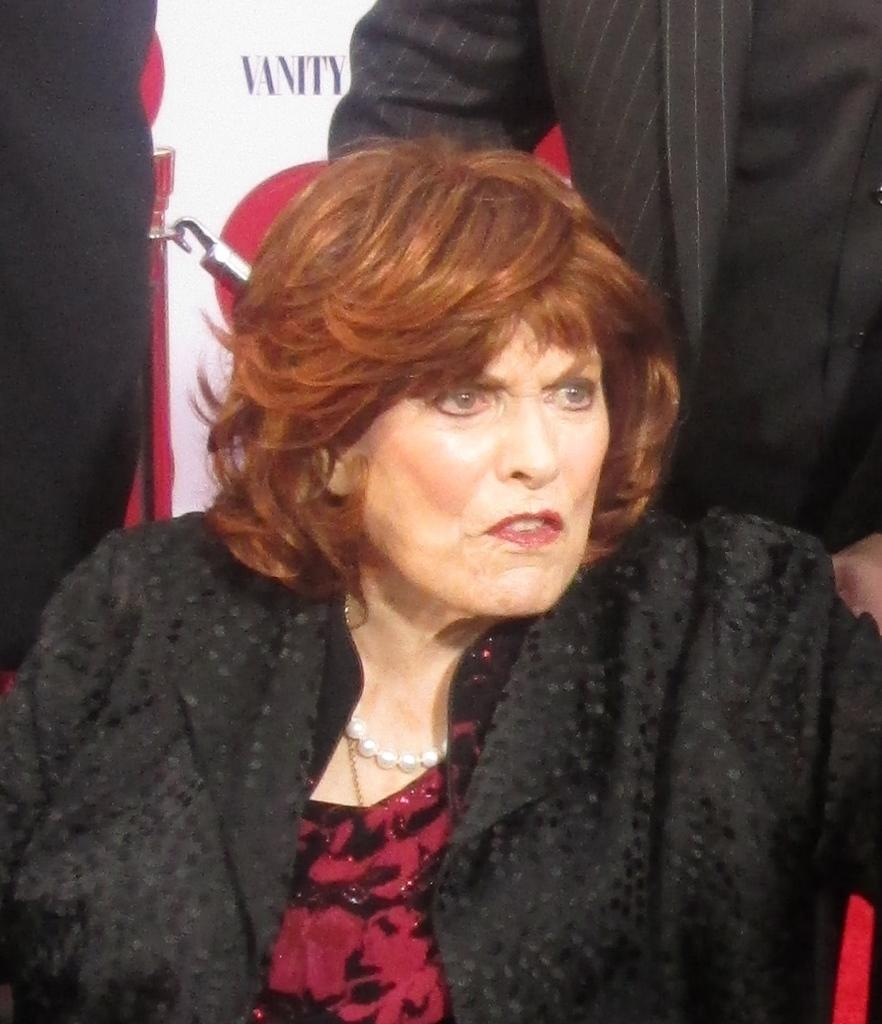Who is the main subject in the image? There is a woman in the image. What is the woman wearing? The woman is wearing a maroon and black dress. Can you describe the background of the image? There are people visible in the background, and there is a white and red color banner. What type of balls are being played with in the image? There are no balls present in the image. Is there a boat visible in the image? No, There is no boat present in the image. 